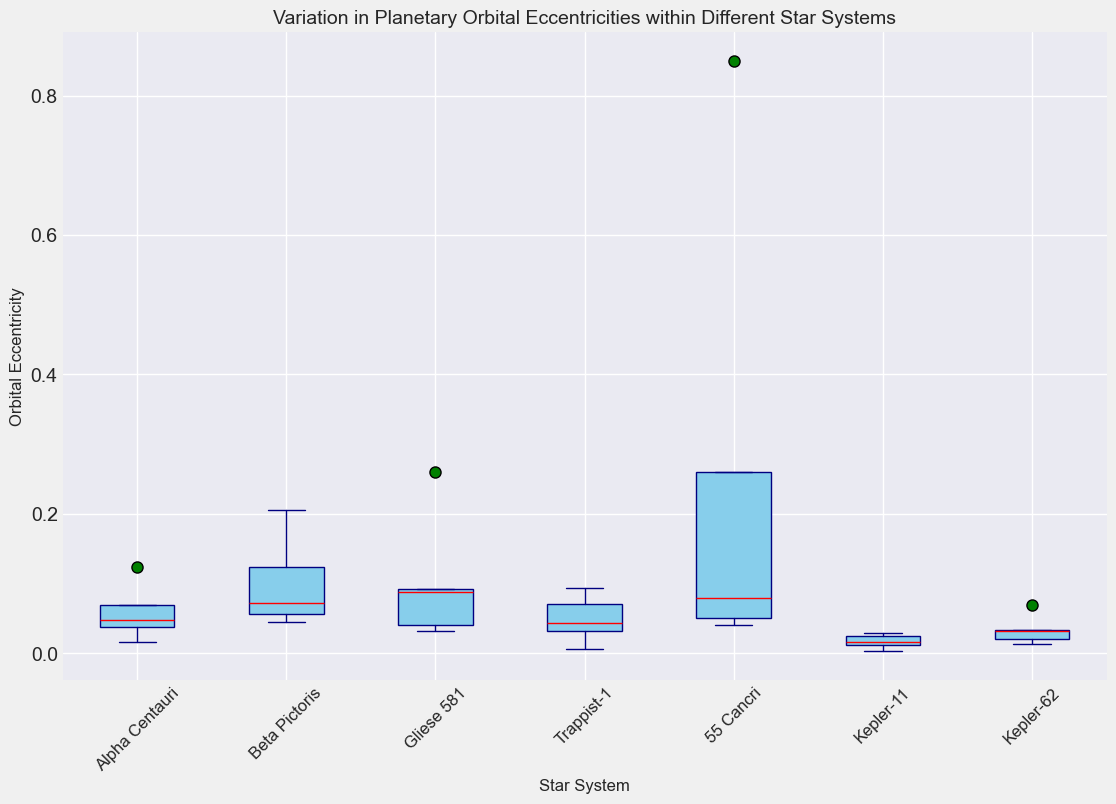What's the range of orbital eccentricities in the Alpha Centauri system? To find the range, look at the difference between the maximum and minimum values within the box plot for Alpha Centauri. The highest value is around 0.124, and the lowest value is around 0.0167. So, the range is 0.124 - 0.0167.
Answer: 0.1073 Which star system has the highest median orbital eccentricity? To determine which star system has the highest median, look for the red line (median) within each box. The highest median, when compared visually, appears to be within 55 Cancri.
Answer: 55 Cancri How do the interquartile ranges of Beta Pictoris and Trappist-1 compare? The interquartile range (IQR) is the difference between the upper quartile (75th percentile) and lower quartile (25th percentile). For Beta Pictoris, the box indicates a wider spread compared to the more compressed box of Trappist-1, showing that Beta Pictoris has a larger IQR.
Answer: Beta Pictoris has a larger IQR Which star system has the smallest spread of orbital eccentricities? The spread is indicated by the length of the whiskers. The smallest spread is where the whiskers and the box are shortest across all star systems, which visibly seems to be Kepler-11.
Answer: Kepler-11 What is notably different about the orbital eccentricities in the 55 Cancri system? Visually, 55 Cancri has a noticeable outlier, a green dot significantly higher than the other values. This indicates extreme variation, unlike other systems.
Answer: It has an extreme outlier Between Alpha Centauri and Gliese 581, which star system shows more variability in orbital eccentricities? Variability can be gauged from the length of the whiskers and the size of the box. Gliese 581's box and whiskers are longer compared to Alpha Centauri, indicating more variability.
Answer: Gliese 581 Which star system has the most consistent orbital eccentricities? Consistency implies a smaller range and smaller IQR. Kepler-11 has the least spread of values and the smallest box, indicating most consistent eccentricities.
Answer: Kepler-11 Considering all the star systems, which system has the lowest median orbital eccentricity? Check the red lines for each star system to find the lowest median. Kepler-11's red line appears to be the lowest, indicating the smallest median eccentricity.
Answer: Kepler-11 